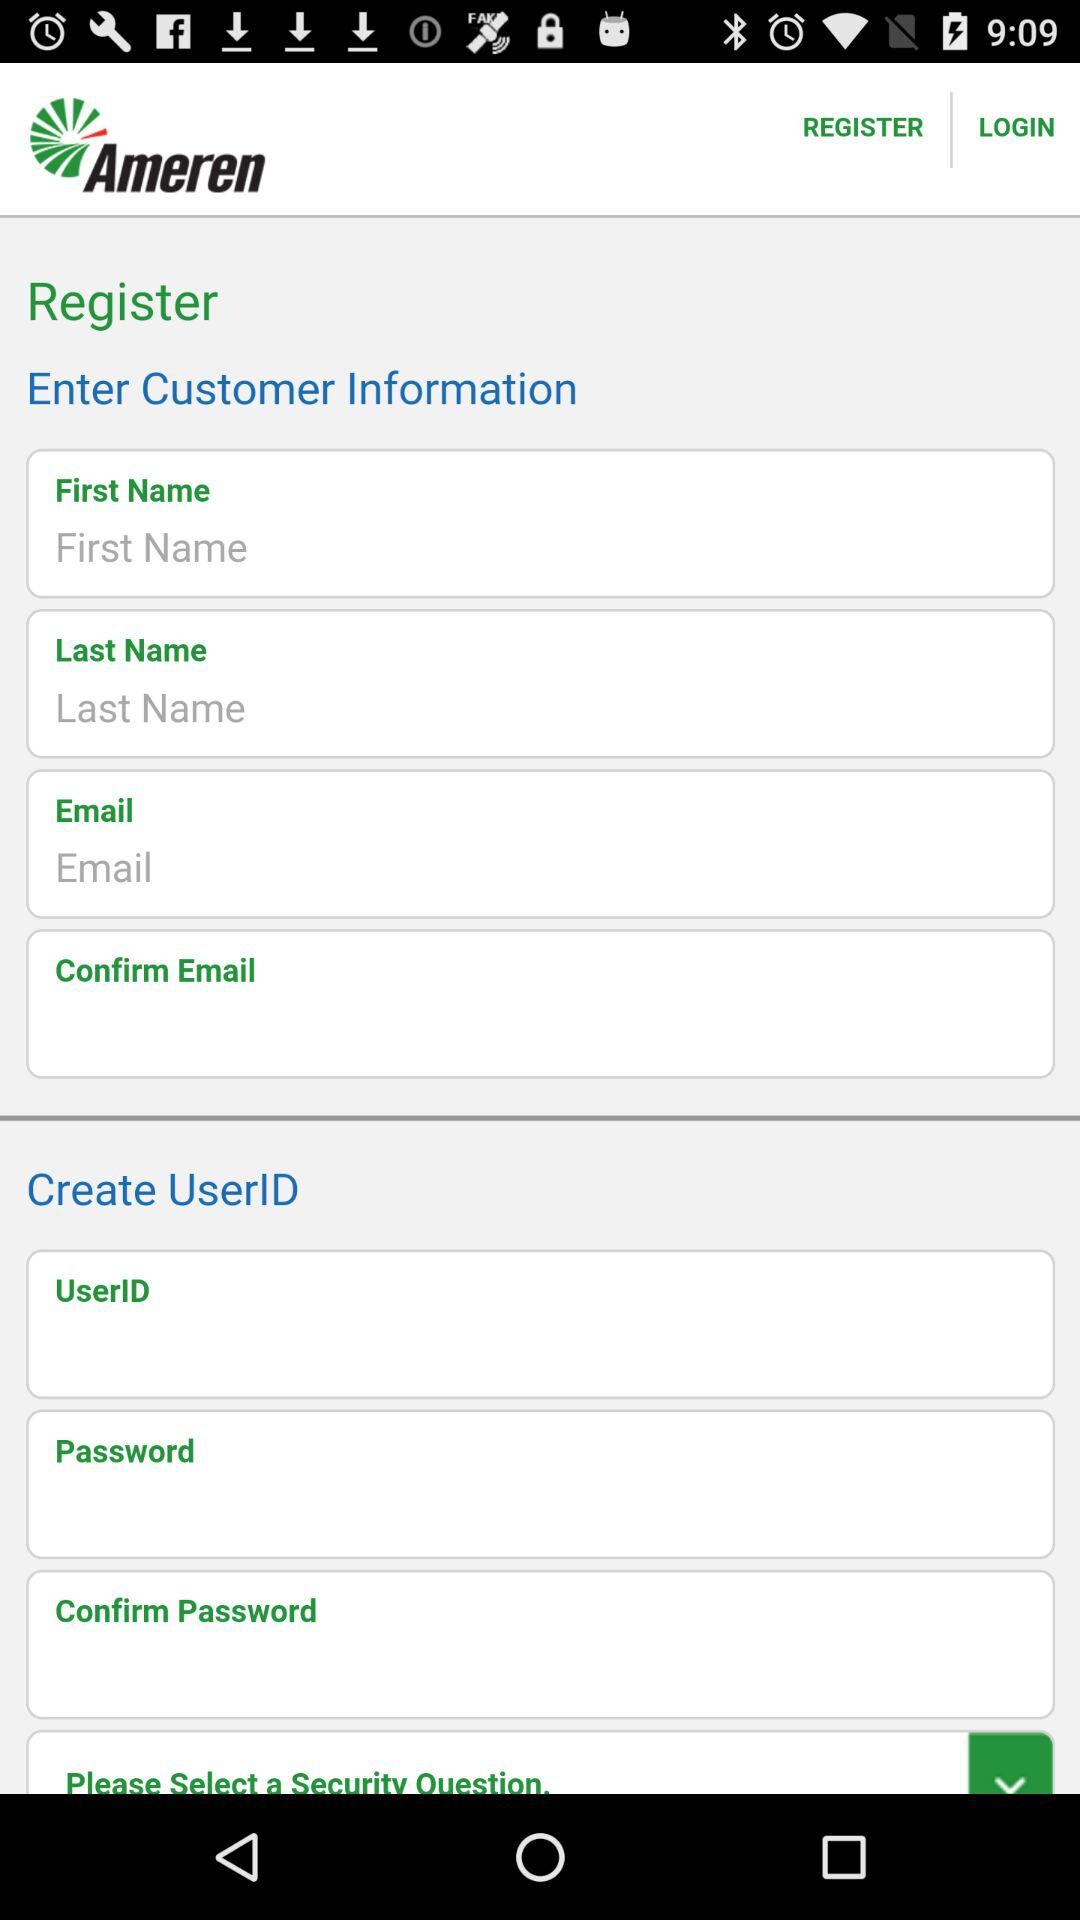What is the name of the application? The name of the application is "Ameren". 